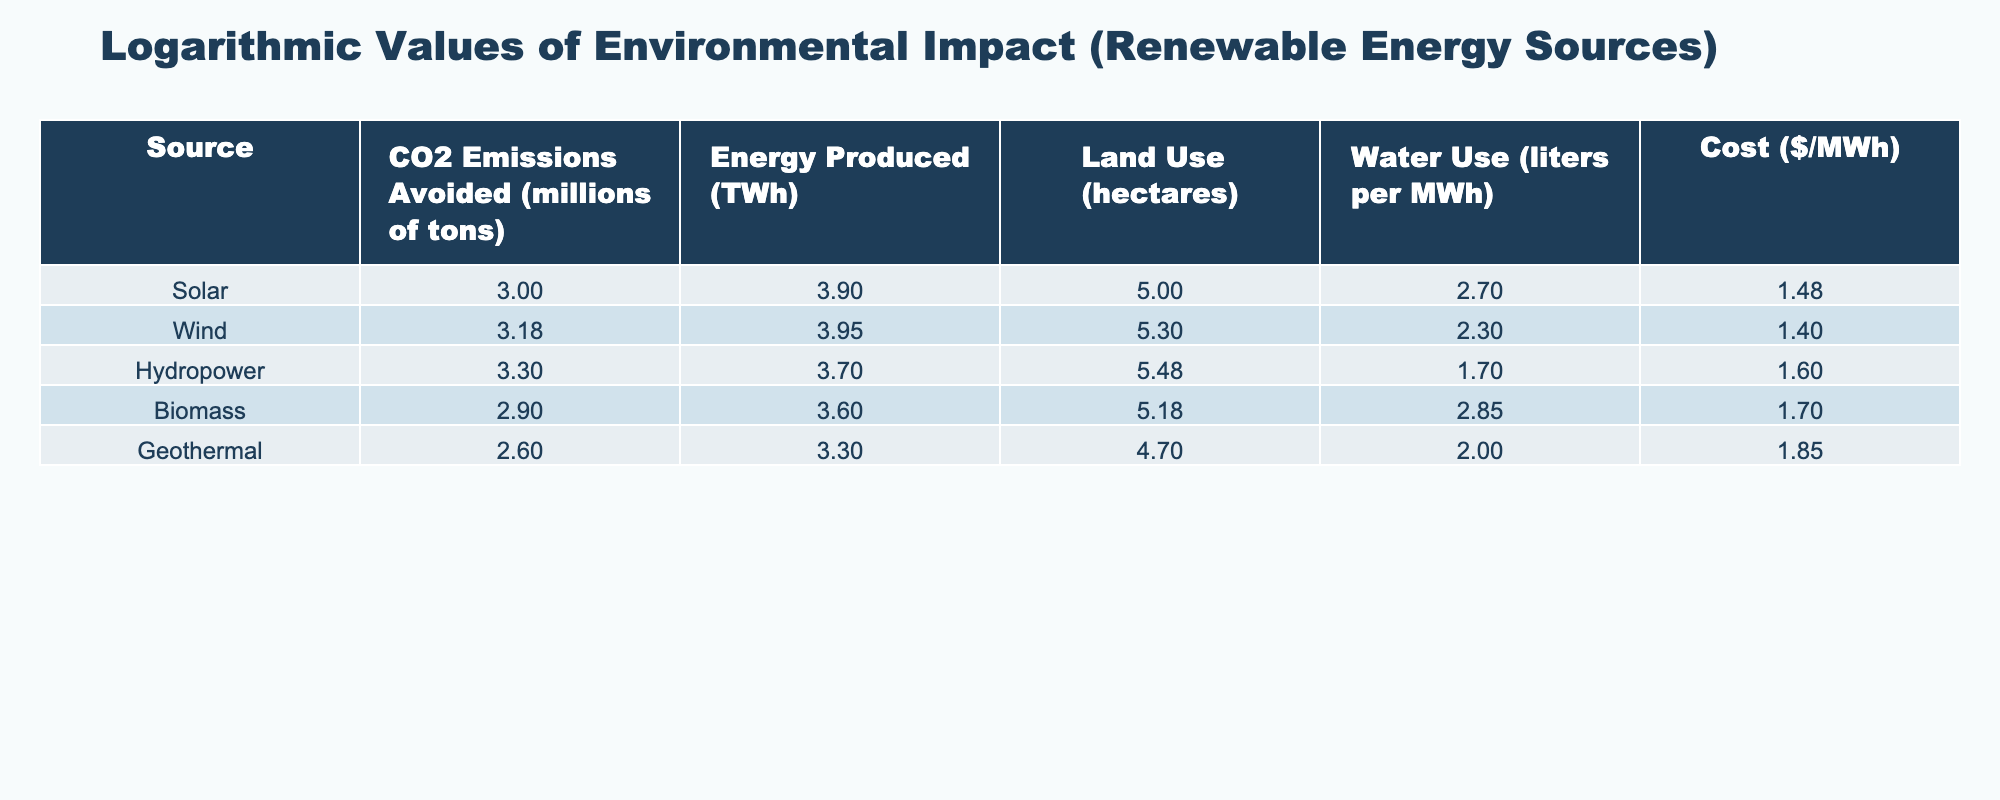What is the CO2 emissions avoided for Wind energy? The value for CO2 emissions avoided that corresponds to Wind energy is provided in the table. It indicates that Wind energy avoids 1,500 million tons of CO2 emissions.
Answer: 1,500 million tons Which renewable energy source has the highest water use per MWh? By comparing the water use per MWh for each energy source, it is noted that Biomass has the highest value at 700 liters per MWh.
Answer: Biomass What is the total CO2 emissions avoided by all renewable energy sources in the table? To find the total CO2 emissions avoided, sum up the values listed for all sources: 1,000 + 1,500 + 2,000 + 800 + 400 = 5,700 million tons.
Answer: 5,700 million tons Does Geothermal energy produce more than 2,500 TWh of energy? The energy produced by Geothermal is 2,000 TWh. Comparing this value against 2,500 TWh shows that Geothermal energy does not produce more, thus the answer is No.
Answer: No What is the average land use for all the renewable energy sources? To determine the average land use, sum the land areas for each source (100,000 + 200,000 + 300,000 + 150,000 + 50,000 = 800,000 hectares) and divide by 5, resulting in 800,000 / 5 = 160,000 hectares.
Answer: 160,000 hectares Is the cost of Solar energy lower than that of Biomass? The costs for Solar and Biomass are given as $30/MWh and $50/MWh, respectively. Since $30 is less than $50, the answer is Yes.
Answer: Yes Which renewable source has the lowest CO2 emissions avoided and what is the value? Reviewing the CO2 emissions avoided across all sources shows Geothermal with the lowest value of 400 million tons.
Answer: Geothermal, 400 million tons What is the difference in energy produced between Wind and Hydropower? The energy produced by Wind is 9,000 TWh and by Hydropower is 5,000 TWh. The difference is calculated as 9,000 - 5,000 = 4,000 TWh.
Answer: 4,000 TWh What renewable energy sources avoid more than 1,000 million tons of CO2 emissions? Examining the CO2 emissions avoided values, sources that meet this criterion are Wind (1,500 million tons) and Hydropower (2,000 million tons) as both exceed 1,000 million tons.
Answer: Wind and Hydropower 